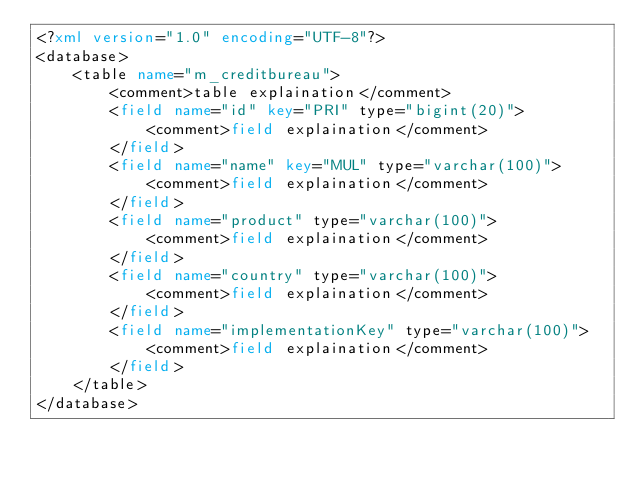Convert code to text. <code><loc_0><loc_0><loc_500><loc_500><_XML_><?xml version="1.0" encoding="UTF-8"?>
<database>
    <table name="m_creditbureau">
        <comment>table explaination</comment>
        <field name="id" key="PRI" type="bigint(20)">
            <comment>field explaination</comment>
        </field>
        <field name="name" key="MUL" type="varchar(100)">
            <comment>field explaination</comment>
        </field>
        <field name="product" type="varchar(100)">
            <comment>field explaination</comment>
        </field>
        <field name="country" type="varchar(100)">
            <comment>field explaination</comment>
        </field>
        <field name="implementationKey" type="varchar(100)">
            <comment>field explaination</comment>
        </field>
    </table>
</database>
</code> 